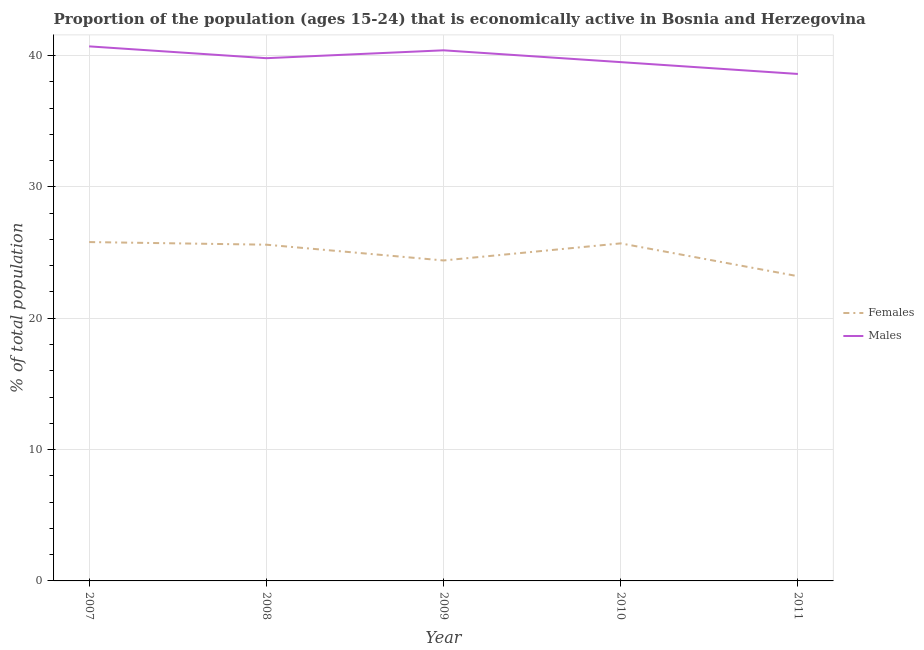What is the percentage of economically active male population in 2008?
Make the answer very short. 39.8. Across all years, what is the maximum percentage of economically active female population?
Provide a short and direct response. 25.8. Across all years, what is the minimum percentage of economically active female population?
Provide a succinct answer. 23.2. In which year was the percentage of economically active male population minimum?
Your answer should be very brief. 2011. What is the total percentage of economically active female population in the graph?
Provide a succinct answer. 124.7. What is the difference between the percentage of economically active male population in 2007 and that in 2009?
Offer a very short reply. 0.3. What is the difference between the percentage of economically active male population in 2007 and the percentage of economically active female population in 2010?
Ensure brevity in your answer.  15. What is the average percentage of economically active female population per year?
Provide a succinct answer. 24.94. In the year 2007, what is the difference between the percentage of economically active female population and percentage of economically active male population?
Provide a succinct answer. -14.9. In how many years, is the percentage of economically active female population greater than 2 %?
Your answer should be very brief. 5. What is the ratio of the percentage of economically active male population in 2007 to that in 2010?
Offer a very short reply. 1.03. Is the percentage of economically active male population in 2009 less than that in 2011?
Your answer should be compact. No. What is the difference between the highest and the second highest percentage of economically active male population?
Provide a succinct answer. 0.3. What is the difference between the highest and the lowest percentage of economically active female population?
Your response must be concise. 2.6. In how many years, is the percentage of economically active female population greater than the average percentage of economically active female population taken over all years?
Offer a very short reply. 3. Is the sum of the percentage of economically active male population in 2007 and 2010 greater than the maximum percentage of economically active female population across all years?
Offer a very short reply. Yes. How many years are there in the graph?
Ensure brevity in your answer.  5. What is the difference between two consecutive major ticks on the Y-axis?
Your response must be concise. 10. Does the graph contain any zero values?
Your response must be concise. No. How many legend labels are there?
Offer a very short reply. 2. How are the legend labels stacked?
Provide a short and direct response. Vertical. What is the title of the graph?
Provide a succinct answer. Proportion of the population (ages 15-24) that is economically active in Bosnia and Herzegovina. Does "Personal remittances" appear as one of the legend labels in the graph?
Provide a succinct answer. No. What is the label or title of the Y-axis?
Make the answer very short. % of total population. What is the % of total population of Females in 2007?
Provide a succinct answer. 25.8. What is the % of total population in Males in 2007?
Offer a very short reply. 40.7. What is the % of total population of Females in 2008?
Offer a very short reply. 25.6. What is the % of total population of Males in 2008?
Provide a short and direct response. 39.8. What is the % of total population of Females in 2009?
Your response must be concise. 24.4. What is the % of total population of Males in 2009?
Give a very brief answer. 40.4. What is the % of total population of Females in 2010?
Make the answer very short. 25.7. What is the % of total population of Males in 2010?
Your answer should be very brief. 39.5. What is the % of total population in Females in 2011?
Offer a terse response. 23.2. What is the % of total population of Males in 2011?
Keep it short and to the point. 38.6. Across all years, what is the maximum % of total population in Females?
Ensure brevity in your answer.  25.8. Across all years, what is the maximum % of total population in Males?
Make the answer very short. 40.7. Across all years, what is the minimum % of total population of Females?
Offer a very short reply. 23.2. Across all years, what is the minimum % of total population of Males?
Keep it short and to the point. 38.6. What is the total % of total population of Females in the graph?
Ensure brevity in your answer.  124.7. What is the total % of total population of Males in the graph?
Provide a short and direct response. 199. What is the difference between the % of total population of Females in 2007 and that in 2008?
Ensure brevity in your answer.  0.2. What is the difference between the % of total population in Males in 2007 and that in 2008?
Provide a succinct answer. 0.9. What is the difference between the % of total population of Females in 2007 and that in 2009?
Give a very brief answer. 1.4. What is the difference between the % of total population of Females in 2007 and that in 2011?
Offer a terse response. 2.6. What is the difference between the % of total population of Females in 2008 and that in 2009?
Ensure brevity in your answer.  1.2. What is the difference between the % of total population in Males in 2008 and that in 2009?
Provide a short and direct response. -0.6. What is the difference between the % of total population in Females in 2008 and that in 2010?
Ensure brevity in your answer.  -0.1. What is the difference between the % of total population of Females in 2009 and that in 2010?
Ensure brevity in your answer.  -1.3. What is the difference between the % of total population in Females in 2009 and that in 2011?
Your answer should be compact. 1.2. What is the difference between the % of total population in Females in 2007 and the % of total population in Males in 2009?
Give a very brief answer. -14.6. What is the difference between the % of total population in Females in 2007 and the % of total population in Males in 2010?
Offer a terse response. -13.7. What is the difference between the % of total population in Females in 2007 and the % of total population in Males in 2011?
Keep it short and to the point. -12.8. What is the difference between the % of total population in Females in 2008 and the % of total population in Males in 2009?
Your answer should be compact. -14.8. What is the difference between the % of total population in Females in 2008 and the % of total population in Males in 2011?
Your answer should be compact. -13. What is the difference between the % of total population of Females in 2009 and the % of total population of Males in 2010?
Offer a terse response. -15.1. What is the difference between the % of total population of Females in 2010 and the % of total population of Males in 2011?
Your answer should be very brief. -12.9. What is the average % of total population in Females per year?
Keep it short and to the point. 24.94. What is the average % of total population of Males per year?
Offer a terse response. 39.8. In the year 2007, what is the difference between the % of total population in Females and % of total population in Males?
Your answer should be compact. -14.9. In the year 2008, what is the difference between the % of total population in Females and % of total population in Males?
Provide a succinct answer. -14.2. In the year 2011, what is the difference between the % of total population in Females and % of total population in Males?
Make the answer very short. -15.4. What is the ratio of the % of total population in Males in 2007 to that in 2008?
Provide a short and direct response. 1.02. What is the ratio of the % of total population in Females in 2007 to that in 2009?
Your answer should be very brief. 1.06. What is the ratio of the % of total population of Males in 2007 to that in 2009?
Your answer should be compact. 1.01. What is the ratio of the % of total population in Females in 2007 to that in 2010?
Ensure brevity in your answer.  1. What is the ratio of the % of total population of Males in 2007 to that in 2010?
Offer a terse response. 1.03. What is the ratio of the % of total population in Females in 2007 to that in 2011?
Keep it short and to the point. 1.11. What is the ratio of the % of total population of Males in 2007 to that in 2011?
Your answer should be compact. 1.05. What is the ratio of the % of total population in Females in 2008 to that in 2009?
Offer a very short reply. 1.05. What is the ratio of the % of total population in Males in 2008 to that in 2009?
Your response must be concise. 0.99. What is the ratio of the % of total population in Males in 2008 to that in 2010?
Provide a short and direct response. 1.01. What is the ratio of the % of total population of Females in 2008 to that in 2011?
Offer a very short reply. 1.1. What is the ratio of the % of total population of Males in 2008 to that in 2011?
Your response must be concise. 1.03. What is the ratio of the % of total population of Females in 2009 to that in 2010?
Keep it short and to the point. 0.95. What is the ratio of the % of total population of Males in 2009 to that in 2010?
Ensure brevity in your answer.  1.02. What is the ratio of the % of total population in Females in 2009 to that in 2011?
Your answer should be very brief. 1.05. What is the ratio of the % of total population of Males in 2009 to that in 2011?
Provide a short and direct response. 1.05. What is the ratio of the % of total population of Females in 2010 to that in 2011?
Make the answer very short. 1.11. What is the ratio of the % of total population in Males in 2010 to that in 2011?
Your response must be concise. 1.02. What is the difference between the highest and the second highest % of total population of Females?
Offer a very short reply. 0.1. What is the difference between the highest and the second highest % of total population of Males?
Offer a very short reply. 0.3. What is the difference between the highest and the lowest % of total population of Males?
Provide a short and direct response. 2.1. 